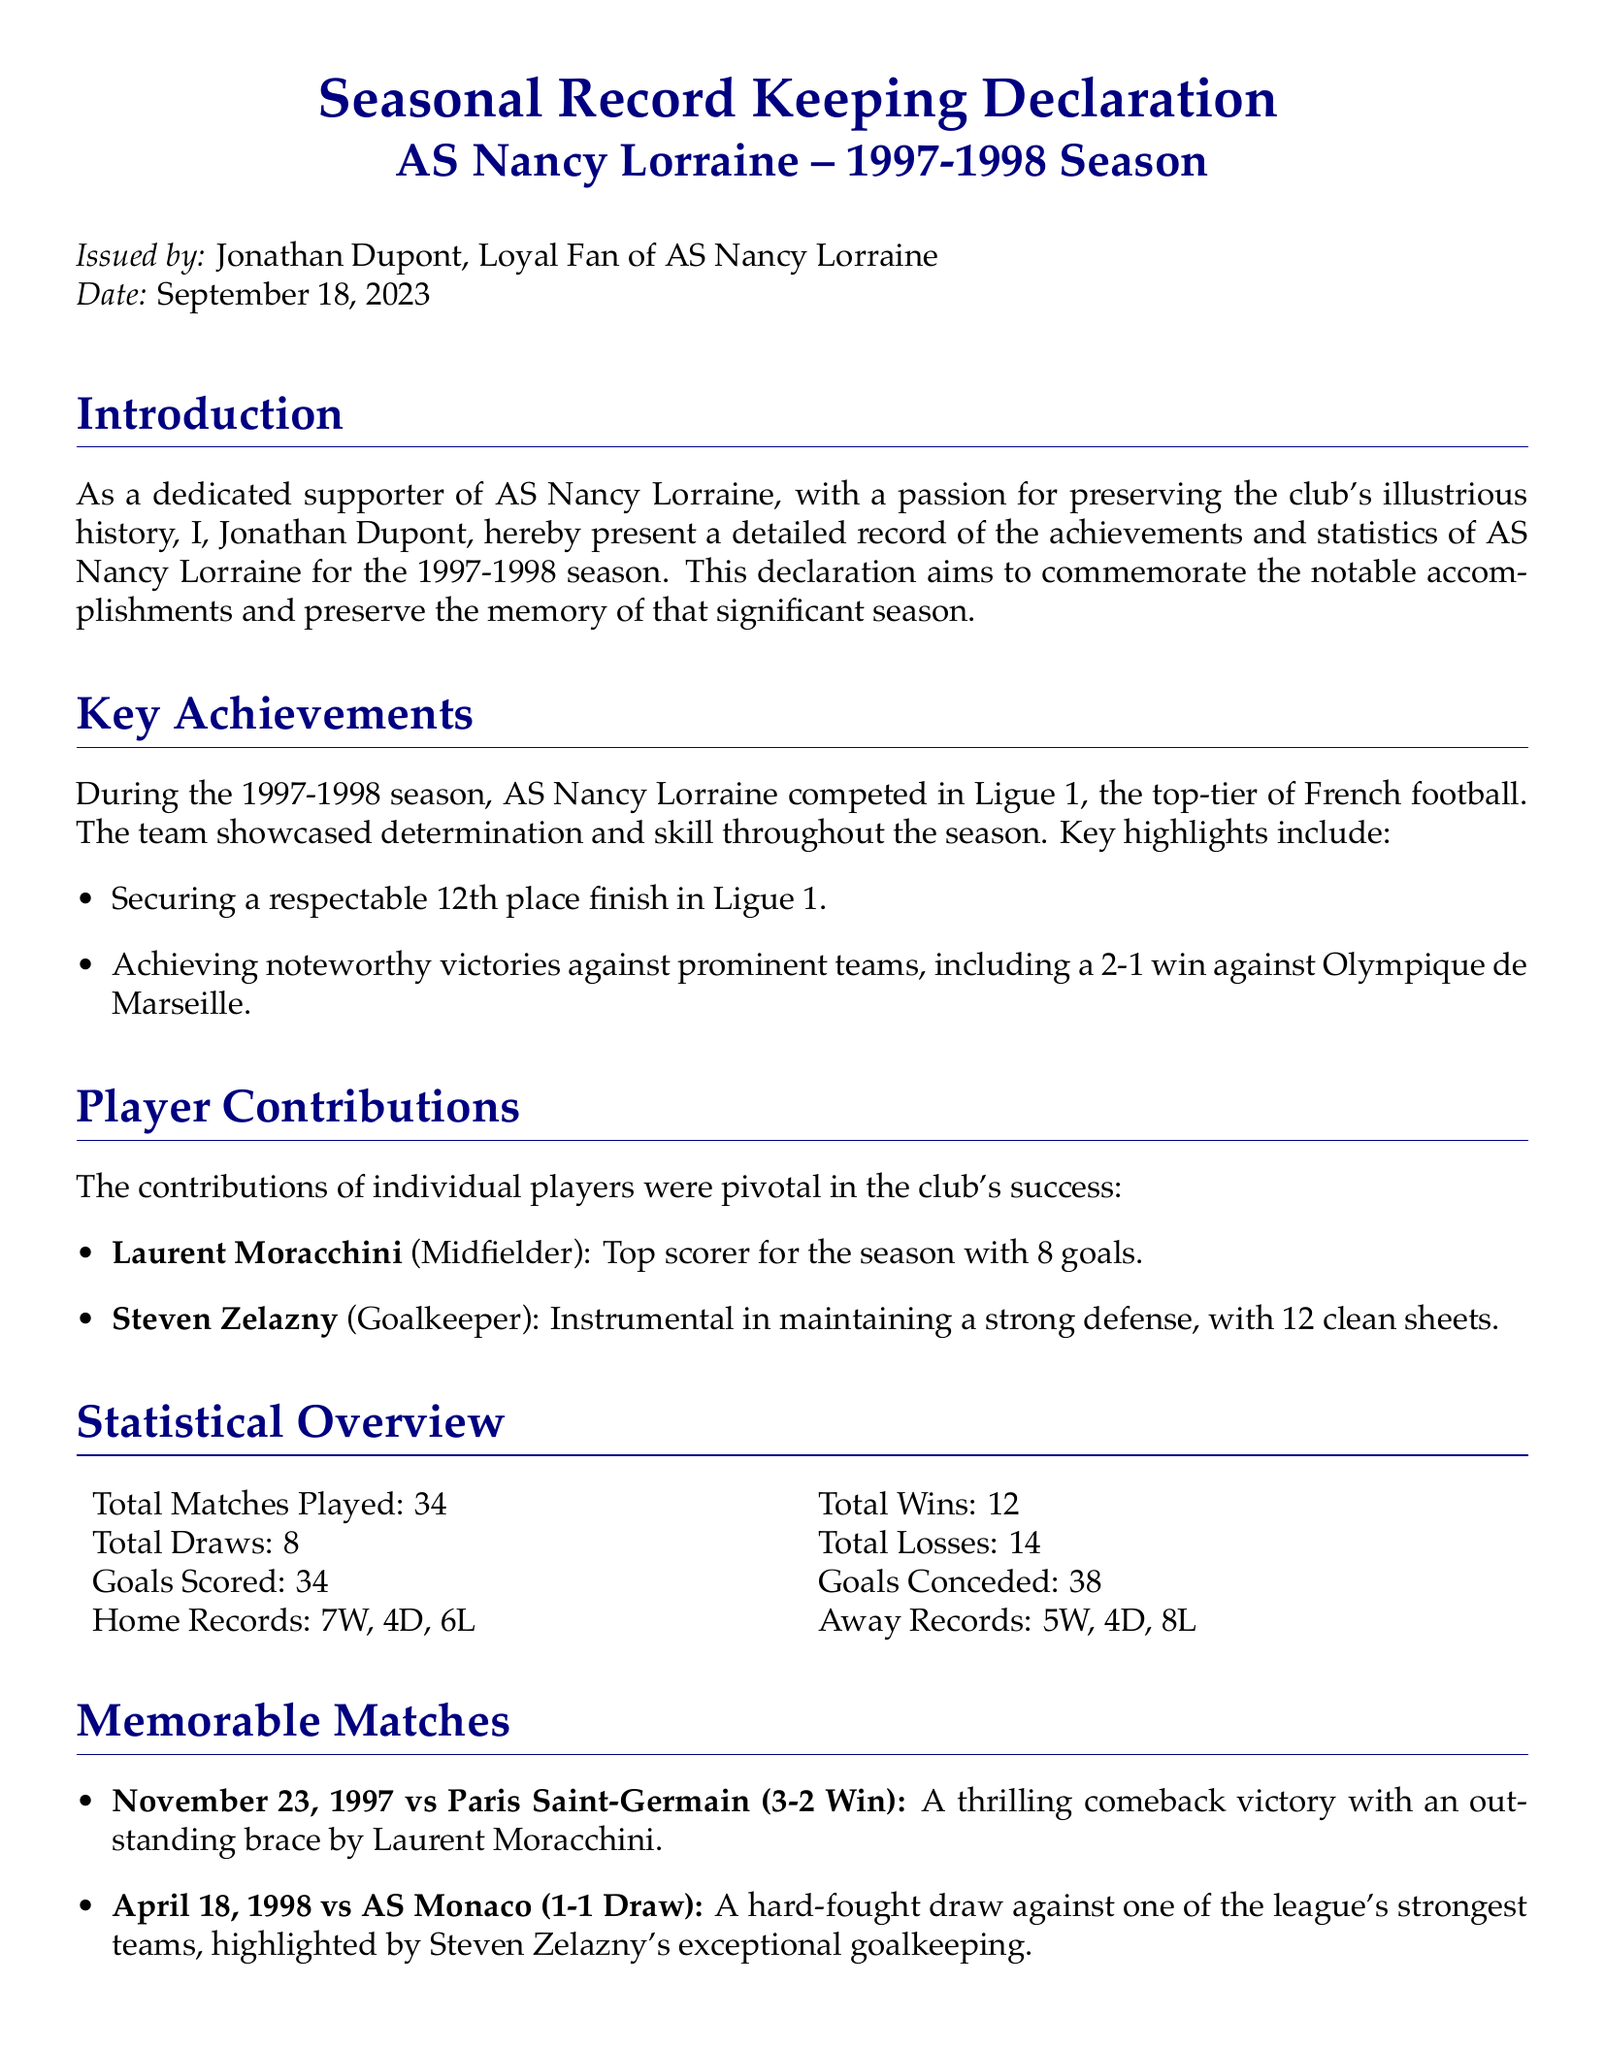What was the total number of matches played? The total number of matches played is stated in the statistical overview section of the document.
Answer: 34 Who was the top scorer for the season? The document mentions Laurent Moracchini as the top scorer in the player contributions section.
Answer: Laurent Moracchini What place did AS Nancy Lorraine finish in Ligue 1? The key achievements section specifies that the team finished in 12th place in Ligue 1.
Answer: 12th place How many clean sheets did Steven Zelazny achieve? The document provides information about the goalkeeper's performance in the player contributions section.
Answer: 12 What was the result of the match against Paris Saint-Germain on November 23, 1997? The memorable matches section describes the victory details against Paris Saint-Germain.
Answer: 3-2 Win Who issued the declaration? The declaration begins with the name of the person who issued it.
Answer: Jonathan Dupont What was the date of issuance for the declaration? The issuance date is explicitly stated in the introductory part of the document.
Answer: September 18, 2023 How many goals were scored by AS Nancy Lorraine during the season? This statistic can be found in the statistical overview section of the document.
Answer: 34 What is the significance of the 1997-1998 season according to the conclusion? The conclusion emphasizes the memorable nature of the season for AS Nancy Lorraine.
Answer: Memorable chapter 